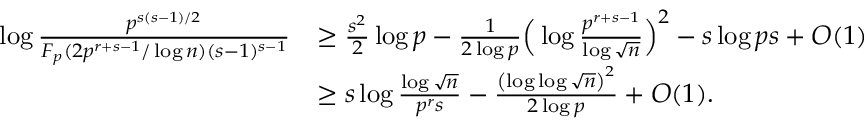<formula> <loc_0><loc_0><loc_500><loc_500>\begin{array} { r l } { \log { \frac { p ^ { s ( s - 1 ) / 2 } } { F _ { p } ( 2 p ^ { r + s - 1 } / \log { n } ) ( s - 1 ) ^ { s - 1 } } } } & { \geq \frac { s ^ { 2 } } { 2 } \log { p } - \frac { 1 } { 2 \log { p } } \left ( \log \frac { p ^ { r + s - 1 } } { \log { \sqrt { n } } } \right ) ^ { 2 } - s \log { p s } + O ( 1 ) } \\ & { \geq s \log { \frac { \log { \sqrt { n } } } { p ^ { r } s } } - \frac { \left ( \log \log { \sqrt { n } } \right ) ^ { 2 } } { 2 \log { p } } + O ( 1 ) . } \end{array}</formula> 